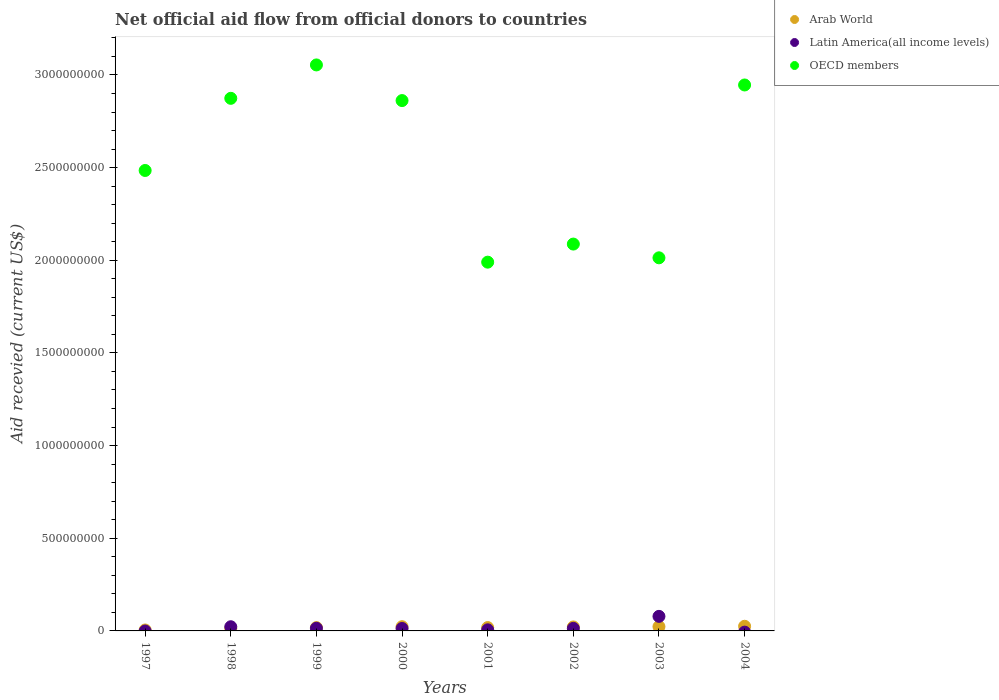How many different coloured dotlines are there?
Make the answer very short. 3. Is the number of dotlines equal to the number of legend labels?
Ensure brevity in your answer.  No. What is the total aid received in OECD members in 2000?
Ensure brevity in your answer.  2.86e+09. Across all years, what is the maximum total aid received in Arab World?
Ensure brevity in your answer.  2.51e+07. In which year was the total aid received in Arab World maximum?
Your answer should be compact. 2004. What is the total total aid received in Latin America(all income levels) in the graph?
Make the answer very short. 1.48e+08. What is the difference between the total aid received in OECD members in 2001 and that in 2003?
Give a very brief answer. -2.34e+07. What is the difference between the total aid received in OECD members in 1998 and the total aid received in Latin America(all income levels) in 1999?
Ensure brevity in your answer.  2.86e+09. What is the average total aid received in Latin America(all income levels) per year?
Offer a very short reply. 1.85e+07. In the year 2003, what is the difference between the total aid received in Arab World and total aid received in Latin America(all income levels)?
Ensure brevity in your answer.  -5.53e+07. In how many years, is the total aid received in OECD members greater than 1100000000 US$?
Ensure brevity in your answer.  8. What is the ratio of the total aid received in OECD members in 1998 to that in 2004?
Make the answer very short. 0.98. Is the total aid received in OECD members in 2000 less than that in 2004?
Provide a succinct answer. Yes. What is the difference between the highest and the second highest total aid received in Arab World?
Give a very brief answer. 1.86e+06. What is the difference between the highest and the lowest total aid received in OECD members?
Ensure brevity in your answer.  1.06e+09. Is the sum of the total aid received in OECD members in 2000 and 2002 greater than the maximum total aid received in Latin America(all income levels) across all years?
Provide a succinct answer. Yes. How many years are there in the graph?
Provide a short and direct response. 8. Does the graph contain grids?
Ensure brevity in your answer.  No. How many legend labels are there?
Provide a succinct answer. 3. What is the title of the graph?
Make the answer very short. Net official aid flow from official donors to countries. What is the label or title of the Y-axis?
Provide a short and direct response. Aid recevied (current US$). What is the Aid recevied (current US$) in Arab World in 1997?
Keep it short and to the point. 5.08e+06. What is the Aid recevied (current US$) in OECD members in 1997?
Provide a succinct answer. 2.48e+09. What is the Aid recevied (current US$) in Arab World in 1998?
Your answer should be compact. 1.31e+07. What is the Aid recevied (current US$) in Latin America(all income levels) in 1998?
Provide a short and direct response. 2.25e+07. What is the Aid recevied (current US$) of OECD members in 1998?
Offer a terse response. 2.87e+09. What is the Aid recevied (current US$) in Arab World in 1999?
Make the answer very short. 1.80e+07. What is the Aid recevied (current US$) of Latin America(all income levels) in 1999?
Ensure brevity in your answer.  1.43e+07. What is the Aid recevied (current US$) of OECD members in 1999?
Provide a short and direct response. 3.05e+09. What is the Aid recevied (current US$) of Arab World in 2000?
Provide a short and direct response. 2.28e+07. What is the Aid recevied (current US$) in Latin America(all income levels) in 2000?
Ensure brevity in your answer.  1.31e+07. What is the Aid recevied (current US$) of OECD members in 2000?
Your answer should be very brief. 2.86e+09. What is the Aid recevied (current US$) of Arab World in 2001?
Offer a terse response. 1.81e+07. What is the Aid recevied (current US$) of Latin America(all income levels) in 2001?
Your answer should be very brief. 5.97e+06. What is the Aid recevied (current US$) in OECD members in 2001?
Keep it short and to the point. 1.99e+09. What is the Aid recevied (current US$) of Arab World in 2002?
Your answer should be very brief. 2.14e+07. What is the Aid recevied (current US$) of Latin America(all income levels) in 2002?
Your answer should be compact. 1.37e+07. What is the Aid recevied (current US$) of OECD members in 2002?
Provide a succinct answer. 2.09e+09. What is the Aid recevied (current US$) of Arab World in 2003?
Make the answer very short. 2.32e+07. What is the Aid recevied (current US$) in Latin America(all income levels) in 2003?
Your response must be concise. 7.86e+07. What is the Aid recevied (current US$) in OECD members in 2003?
Your answer should be very brief. 2.01e+09. What is the Aid recevied (current US$) in Arab World in 2004?
Offer a terse response. 2.51e+07. What is the Aid recevied (current US$) in OECD members in 2004?
Your answer should be compact. 2.95e+09. Across all years, what is the maximum Aid recevied (current US$) of Arab World?
Ensure brevity in your answer.  2.51e+07. Across all years, what is the maximum Aid recevied (current US$) in Latin America(all income levels)?
Your response must be concise. 7.86e+07. Across all years, what is the maximum Aid recevied (current US$) of OECD members?
Make the answer very short. 3.05e+09. Across all years, what is the minimum Aid recevied (current US$) of Arab World?
Keep it short and to the point. 5.08e+06. Across all years, what is the minimum Aid recevied (current US$) in Latin America(all income levels)?
Offer a terse response. 0. Across all years, what is the minimum Aid recevied (current US$) in OECD members?
Your answer should be very brief. 1.99e+09. What is the total Aid recevied (current US$) of Arab World in the graph?
Keep it short and to the point. 1.47e+08. What is the total Aid recevied (current US$) in Latin America(all income levels) in the graph?
Your response must be concise. 1.48e+08. What is the total Aid recevied (current US$) in OECD members in the graph?
Give a very brief answer. 2.03e+1. What is the difference between the Aid recevied (current US$) of Arab World in 1997 and that in 1998?
Make the answer very short. -8.03e+06. What is the difference between the Aid recevied (current US$) of OECD members in 1997 and that in 1998?
Make the answer very short. -3.89e+08. What is the difference between the Aid recevied (current US$) in Arab World in 1997 and that in 1999?
Make the answer very short. -1.29e+07. What is the difference between the Aid recevied (current US$) in OECD members in 1997 and that in 1999?
Offer a terse response. -5.70e+08. What is the difference between the Aid recevied (current US$) of Arab World in 1997 and that in 2000?
Provide a short and direct response. -1.77e+07. What is the difference between the Aid recevied (current US$) of OECD members in 1997 and that in 2000?
Offer a very short reply. -3.77e+08. What is the difference between the Aid recevied (current US$) of Arab World in 1997 and that in 2001?
Provide a short and direct response. -1.30e+07. What is the difference between the Aid recevied (current US$) of OECD members in 1997 and that in 2001?
Make the answer very short. 4.95e+08. What is the difference between the Aid recevied (current US$) in Arab World in 1997 and that in 2002?
Provide a succinct answer. -1.64e+07. What is the difference between the Aid recevied (current US$) in OECD members in 1997 and that in 2002?
Give a very brief answer. 3.97e+08. What is the difference between the Aid recevied (current US$) of Arab World in 1997 and that in 2003?
Provide a short and direct response. -1.82e+07. What is the difference between the Aid recevied (current US$) in OECD members in 1997 and that in 2003?
Provide a succinct answer. 4.71e+08. What is the difference between the Aid recevied (current US$) of Arab World in 1997 and that in 2004?
Offer a terse response. -2.00e+07. What is the difference between the Aid recevied (current US$) of OECD members in 1997 and that in 2004?
Make the answer very short. -4.61e+08. What is the difference between the Aid recevied (current US$) of Arab World in 1998 and that in 1999?
Provide a short and direct response. -4.89e+06. What is the difference between the Aid recevied (current US$) in Latin America(all income levels) in 1998 and that in 1999?
Offer a terse response. 8.20e+06. What is the difference between the Aid recevied (current US$) of OECD members in 1998 and that in 1999?
Provide a succinct answer. -1.80e+08. What is the difference between the Aid recevied (current US$) of Arab World in 1998 and that in 2000?
Keep it short and to the point. -9.67e+06. What is the difference between the Aid recevied (current US$) in Latin America(all income levels) in 1998 and that in 2000?
Make the answer very short. 9.40e+06. What is the difference between the Aid recevied (current US$) of OECD members in 1998 and that in 2000?
Provide a short and direct response. 1.22e+07. What is the difference between the Aid recevied (current US$) of Arab World in 1998 and that in 2001?
Keep it short and to the point. -5.00e+06. What is the difference between the Aid recevied (current US$) in Latin America(all income levels) in 1998 and that in 2001?
Make the answer very short. 1.66e+07. What is the difference between the Aid recevied (current US$) of OECD members in 1998 and that in 2001?
Give a very brief answer. 8.84e+08. What is the difference between the Aid recevied (current US$) of Arab World in 1998 and that in 2002?
Give a very brief answer. -8.33e+06. What is the difference between the Aid recevied (current US$) of Latin America(all income levels) in 1998 and that in 2002?
Make the answer very short. 8.82e+06. What is the difference between the Aid recevied (current US$) in OECD members in 1998 and that in 2002?
Your response must be concise. 7.86e+08. What is the difference between the Aid recevied (current US$) of Arab World in 1998 and that in 2003?
Offer a very short reply. -1.01e+07. What is the difference between the Aid recevied (current US$) in Latin America(all income levels) in 1998 and that in 2003?
Your response must be concise. -5.60e+07. What is the difference between the Aid recevied (current US$) of OECD members in 1998 and that in 2003?
Offer a very short reply. 8.61e+08. What is the difference between the Aid recevied (current US$) of Arab World in 1998 and that in 2004?
Your answer should be very brief. -1.20e+07. What is the difference between the Aid recevied (current US$) of OECD members in 1998 and that in 2004?
Ensure brevity in your answer.  -7.20e+07. What is the difference between the Aid recevied (current US$) of Arab World in 1999 and that in 2000?
Your answer should be compact. -4.78e+06. What is the difference between the Aid recevied (current US$) of Latin America(all income levels) in 1999 and that in 2000?
Give a very brief answer. 1.20e+06. What is the difference between the Aid recevied (current US$) in OECD members in 1999 and that in 2000?
Offer a very short reply. 1.92e+08. What is the difference between the Aid recevied (current US$) of Latin America(all income levels) in 1999 and that in 2001?
Your response must be concise. 8.36e+06. What is the difference between the Aid recevied (current US$) in OECD members in 1999 and that in 2001?
Offer a terse response. 1.06e+09. What is the difference between the Aid recevied (current US$) in Arab World in 1999 and that in 2002?
Your answer should be very brief. -3.44e+06. What is the difference between the Aid recevied (current US$) of Latin America(all income levels) in 1999 and that in 2002?
Ensure brevity in your answer.  6.20e+05. What is the difference between the Aid recevied (current US$) of OECD members in 1999 and that in 2002?
Your answer should be very brief. 9.67e+08. What is the difference between the Aid recevied (current US$) of Arab World in 1999 and that in 2003?
Provide a succinct answer. -5.25e+06. What is the difference between the Aid recevied (current US$) in Latin America(all income levels) in 1999 and that in 2003?
Keep it short and to the point. -6.42e+07. What is the difference between the Aid recevied (current US$) of OECD members in 1999 and that in 2003?
Ensure brevity in your answer.  1.04e+09. What is the difference between the Aid recevied (current US$) of Arab World in 1999 and that in 2004?
Provide a short and direct response. -7.11e+06. What is the difference between the Aid recevied (current US$) in OECD members in 1999 and that in 2004?
Provide a succinct answer. 1.08e+08. What is the difference between the Aid recevied (current US$) of Arab World in 2000 and that in 2001?
Give a very brief answer. 4.67e+06. What is the difference between the Aid recevied (current US$) of Latin America(all income levels) in 2000 and that in 2001?
Provide a succinct answer. 7.16e+06. What is the difference between the Aid recevied (current US$) in OECD members in 2000 and that in 2001?
Ensure brevity in your answer.  8.72e+08. What is the difference between the Aid recevied (current US$) of Arab World in 2000 and that in 2002?
Your answer should be very brief. 1.34e+06. What is the difference between the Aid recevied (current US$) of Latin America(all income levels) in 2000 and that in 2002?
Give a very brief answer. -5.80e+05. What is the difference between the Aid recevied (current US$) in OECD members in 2000 and that in 2002?
Make the answer very short. 7.74e+08. What is the difference between the Aid recevied (current US$) in Arab World in 2000 and that in 2003?
Offer a very short reply. -4.70e+05. What is the difference between the Aid recevied (current US$) of Latin America(all income levels) in 2000 and that in 2003?
Your answer should be very brief. -6.54e+07. What is the difference between the Aid recevied (current US$) of OECD members in 2000 and that in 2003?
Provide a short and direct response. 8.48e+08. What is the difference between the Aid recevied (current US$) in Arab World in 2000 and that in 2004?
Provide a short and direct response. -2.33e+06. What is the difference between the Aid recevied (current US$) in OECD members in 2000 and that in 2004?
Make the answer very short. -8.42e+07. What is the difference between the Aid recevied (current US$) of Arab World in 2001 and that in 2002?
Offer a terse response. -3.33e+06. What is the difference between the Aid recevied (current US$) of Latin America(all income levels) in 2001 and that in 2002?
Provide a short and direct response. -7.74e+06. What is the difference between the Aid recevied (current US$) in OECD members in 2001 and that in 2002?
Make the answer very short. -9.76e+07. What is the difference between the Aid recevied (current US$) of Arab World in 2001 and that in 2003?
Keep it short and to the point. -5.14e+06. What is the difference between the Aid recevied (current US$) of Latin America(all income levels) in 2001 and that in 2003?
Give a very brief answer. -7.26e+07. What is the difference between the Aid recevied (current US$) of OECD members in 2001 and that in 2003?
Your answer should be compact. -2.34e+07. What is the difference between the Aid recevied (current US$) in Arab World in 2001 and that in 2004?
Offer a terse response. -7.00e+06. What is the difference between the Aid recevied (current US$) of OECD members in 2001 and that in 2004?
Provide a succinct answer. -9.56e+08. What is the difference between the Aid recevied (current US$) of Arab World in 2002 and that in 2003?
Offer a terse response. -1.81e+06. What is the difference between the Aid recevied (current US$) of Latin America(all income levels) in 2002 and that in 2003?
Your answer should be compact. -6.49e+07. What is the difference between the Aid recevied (current US$) in OECD members in 2002 and that in 2003?
Offer a very short reply. 7.41e+07. What is the difference between the Aid recevied (current US$) of Arab World in 2002 and that in 2004?
Provide a short and direct response. -3.67e+06. What is the difference between the Aid recevied (current US$) of OECD members in 2002 and that in 2004?
Your answer should be compact. -8.58e+08. What is the difference between the Aid recevied (current US$) of Arab World in 2003 and that in 2004?
Offer a very short reply. -1.86e+06. What is the difference between the Aid recevied (current US$) of OECD members in 2003 and that in 2004?
Offer a very short reply. -9.33e+08. What is the difference between the Aid recevied (current US$) of Arab World in 1997 and the Aid recevied (current US$) of Latin America(all income levels) in 1998?
Ensure brevity in your answer.  -1.74e+07. What is the difference between the Aid recevied (current US$) in Arab World in 1997 and the Aid recevied (current US$) in OECD members in 1998?
Your response must be concise. -2.87e+09. What is the difference between the Aid recevied (current US$) in Arab World in 1997 and the Aid recevied (current US$) in Latin America(all income levels) in 1999?
Offer a very short reply. -9.25e+06. What is the difference between the Aid recevied (current US$) of Arab World in 1997 and the Aid recevied (current US$) of OECD members in 1999?
Ensure brevity in your answer.  -3.05e+09. What is the difference between the Aid recevied (current US$) of Arab World in 1997 and the Aid recevied (current US$) of Latin America(all income levels) in 2000?
Ensure brevity in your answer.  -8.05e+06. What is the difference between the Aid recevied (current US$) in Arab World in 1997 and the Aid recevied (current US$) in OECD members in 2000?
Provide a short and direct response. -2.86e+09. What is the difference between the Aid recevied (current US$) of Arab World in 1997 and the Aid recevied (current US$) of Latin America(all income levels) in 2001?
Give a very brief answer. -8.90e+05. What is the difference between the Aid recevied (current US$) in Arab World in 1997 and the Aid recevied (current US$) in OECD members in 2001?
Make the answer very short. -1.98e+09. What is the difference between the Aid recevied (current US$) of Arab World in 1997 and the Aid recevied (current US$) of Latin America(all income levels) in 2002?
Ensure brevity in your answer.  -8.63e+06. What is the difference between the Aid recevied (current US$) in Arab World in 1997 and the Aid recevied (current US$) in OECD members in 2002?
Make the answer very short. -2.08e+09. What is the difference between the Aid recevied (current US$) of Arab World in 1997 and the Aid recevied (current US$) of Latin America(all income levels) in 2003?
Provide a short and direct response. -7.35e+07. What is the difference between the Aid recevied (current US$) in Arab World in 1997 and the Aid recevied (current US$) in OECD members in 2003?
Your answer should be compact. -2.01e+09. What is the difference between the Aid recevied (current US$) of Arab World in 1997 and the Aid recevied (current US$) of OECD members in 2004?
Ensure brevity in your answer.  -2.94e+09. What is the difference between the Aid recevied (current US$) of Arab World in 1998 and the Aid recevied (current US$) of Latin America(all income levels) in 1999?
Keep it short and to the point. -1.22e+06. What is the difference between the Aid recevied (current US$) of Arab World in 1998 and the Aid recevied (current US$) of OECD members in 1999?
Offer a very short reply. -3.04e+09. What is the difference between the Aid recevied (current US$) of Latin America(all income levels) in 1998 and the Aid recevied (current US$) of OECD members in 1999?
Provide a succinct answer. -3.03e+09. What is the difference between the Aid recevied (current US$) in Arab World in 1998 and the Aid recevied (current US$) in OECD members in 2000?
Offer a terse response. -2.85e+09. What is the difference between the Aid recevied (current US$) in Latin America(all income levels) in 1998 and the Aid recevied (current US$) in OECD members in 2000?
Provide a short and direct response. -2.84e+09. What is the difference between the Aid recevied (current US$) of Arab World in 1998 and the Aid recevied (current US$) of Latin America(all income levels) in 2001?
Offer a very short reply. 7.14e+06. What is the difference between the Aid recevied (current US$) of Arab World in 1998 and the Aid recevied (current US$) of OECD members in 2001?
Ensure brevity in your answer.  -1.98e+09. What is the difference between the Aid recevied (current US$) in Latin America(all income levels) in 1998 and the Aid recevied (current US$) in OECD members in 2001?
Your response must be concise. -1.97e+09. What is the difference between the Aid recevied (current US$) of Arab World in 1998 and the Aid recevied (current US$) of Latin America(all income levels) in 2002?
Keep it short and to the point. -6.00e+05. What is the difference between the Aid recevied (current US$) in Arab World in 1998 and the Aid recevied (current US$) in OECD members in 2002?
Your answer should be very brief. -2.07e+09. What is the difference between the Aid recevied (current US$) of Latin America(all income levels) in 1998 and the Aid recevied (current US$) of OECD members in 2002?
Make the answer very short. -2.06e+09. What is the difference between the Aid recevied (current US$) of Arab World in 1998 and the Aid recevied (current US$) of Latin America(all income levels) in 2003?
Make the answer very short. -6.55e+07. What is the difference between the Aid recevied (current US$) of Arab World in 1998 and the Aid recevied (current US$) of OECD members in 2003?
Provide a short and direct response. -2.00e+09. What is the difference between the Aid recevied (current US$) in Latin America(all income levels) in 1998 and the Aid recevied (current US$) in OECD members in 2003?
Offer a terse response. -1.99e+09. What is the difference between the Aid recevied (current US$) of Arab World in 1998 and the Aid recevied (current US$) of OECD members in 2004?
Your response must be concise. -2.93e+09. What is the difference between the Aid recevied (current US$) of Latin America(all income levels) in 1998 and the Aid recevied (current US$) of OECD members in 2004?
Make the answer very short. -2.92e+09. What is the difference between the Aid recevied (current US$) in Arab World in 1999 and the Aid recevied (current US$) in Latin America(all income levels) in 2000?
Provide a succinct answer. 4.87e+06. What is the difference between the Aid recevied (current US$) of Arab World in 1999 and the Aid recevied (current US$) of OECD members in 2000?
Offer a very short reply. -2.84e+09. What is the difference between the Aid recevied (current US$) of Latin America(all income levels) in 1999 and the Aid recevied (current US$) of OECD members in 2000?
Provide a succinct answer. -2.85e+09. What is the difference between the Aid recevied (current US$) of Arab World in 1999 and the Aid recevied (current US$) of Latin America(all income levels) in 2001?
Your answer should be very brief. 1.20e+07. What is the difference between the Aid recevied (current US$) of Arab World in 1999 and the Aid recevied (current US$) of OECD members in 2001?
Your answer should be very brief. -1.97e+09. What is the difference between the Aid recevied (current US$) in Latin America(all income levels) in 1999 and the Aid recevied (current US$) in OECD members in 2001?
Keep it short and to the point. -1.98e+09. What is the difference between the Aid recevied (current US$) in Arab World in 1999 and the Aid recevied (current US$) in Latin America(all income levels) in 2002?
Your answer should be compact. 4.29e+06. What is the difference between the Aid recevied (current US$) in Arab World in 1999 and the Aid recevied (current US$) in OECD members in 2002?
Your answer should be very brief. -2.07e+09. What is the difference between the Aid recevied (current US$) in Latin America(all income levels) in 1999 and the Aid recevied (current US$) in OECD members in 2002?
Provide a short and direct response. -2.07e+09. What is the difference between the Aid recevied (current US$) of Arab World in 1999 and the Aid recevied (current US$) of Latin America(all income levels) in 2003?
Your answer should be very brief. -6.06e+07. What is the difference between the Aid recevied (current US$) of Arab World in 1999 and the Aid recevied (current US$) of OECD members in 2003?
Provide a short and direct response. -2.00e+09. What is the difference between the Aid recevied (current US$) in Latin America(all income levels) in 1999 and the Aid recevied (current US$) in OECD members in 2003?
Keep it short and to the point. -2.00e+09. What is the difference between the Aid recevied (current US$) of Arab World in 1999 and the Aid recevied (current US$) of OECD members in 2004?
Ensure brevity in your answer.  -2.93e+09. What is the difference between the Aid recevied (current US$) of Latin America(all income levels) in 1999 and the Aid recevied (current US$) of OECD members in 2004?
Your response must be concise. -2.93e+09. What is the difference between the Aid recevied (current US$) in Arab World in 2000 and the Aid recevied (current US$) in Latin America(all income levels) in 2001?
Your response must be concise. 1.68e+07. What is the difference between the Aid recevied (current US$) in Arab World in 2000 and the Aid recevied (current US$) in OECD members in 2001?
Your answer should be very brief. -1.97e+09. What is the difference between the Aid recevied (current US$) of Latin America(all income levels) in 2000 and the Aid recevied (current US$) of OECD members in 2001?
Provide a short and direct response. -1.98e+09. What is the difference between the Aid recevied (current US$) of Arab World in 2000 and the Aid recevied (current US$) of Latin America(all income levels) in 2002?
Offer a terse response. 9.07e+06. What is the difference between the Aid recevied (current US$) of Arab World in 2000 and the Aid recevied (current US$) of OECD members in 2002?
Your answer should be very brief. -2.06e+09. What is the difference between the Aid recevied (current US$) in Latin America(all income levels) in 2000 and the Aid recevied (current US$) in OECD members in 2002?
Give a very brief answer. -2.07e+09. What is the difference between the Aid recevied (current US$) of Arab World in 2000 and the Aid recevied (current US$) of Latin America(all income levels) in 2003?
Your answer should be very brief. -5.58e+07. What is the difference between the Aid recevied (current US$) in Arab World in 2000 and the Aid recevied (current US$) in OECD members in 2003?
Offer a very short reply. -1.99e+09. What is the difference between the Aid recevied (current US$) in Latin America(all income levels) in 2000 and the Aid recevied (current US$) in OECD members in 2003?
Provide a short and direct response. -2.00e+09. What is the difference between the Aid recevied (current US$) in Arab World in 2000 and the Aid recevied (current US$) in OECD members in 2004?
Offer a terse response. -2.92e+09. What is the difference between the Aid recevied (current US$) in Latin America(all income levels) in 2000 and the Aid recevied (current US$) in OECD members in 2004?
Your answer should be compact. -2.93e+09. What is the difference between the Aid recevied (current US$) in Arab World in 2001 and the Aid recevied (current US$) in Latin America(all income levels) in 2002?
Offer a very short reply. 4.40e+06. What is the difference between the Aid recevied (current US$) of Arab World in 2001 and the Aid recevied (current US$) of OECD members in 2002?
Provide a succinct answer. -2.07e+09. What is the difference between the Aid recevied (current US$) of Latin America(all income levels) in 2001 and the Aid recevied (current US$) of OECD members in 2002?
Your answer should be compact. -2.08e+09. What is the difference between the Aid recevied (current US$) of Arab World in 2001 and the Aid recevied (current US$) of Latin America(all income levels) in 2003?
Your answer should be very brief. -6.05e+07. What is the difference between the Aid recevied (current US$) in Arab World in 2001 and the Aid recevied (current US$) in OECD members in 2003?
Offer a very short reply. -2.00e+09. What is the difference between the Aid recevied (current US$) of Latin America(all income levels) in 2001 and the Aid recevied (current US$) of OECD members in 2003?
Keep it short and to the point. -2.01e+09. What is the difference between the Aid recevied (current US$) of Arab World in 2001 and the Aid recevied (current US$) of OECD members in 2004?
Offer a very short reply. -2.93e+09. What is the difference between the Aid recevied (current US$) of Latin America(all income levels) in 2001 and the Aid recevied (current US$) of OECD members in 2004?
Make the answer very short. -2.94e+09. What is the difference between the Aid recevied (current US$) of Arab World in 2002 and the Aid recevied (current US$) of Latin America(all income levels) in 2003?
Make the answer very short. -5.71e+07. What is the difference between the Aid recevied (current US$) of Arab World in 2002 and the Aid recevied (current US$) of OECD members in 2003?
Your answer should be very brief. -1.99e+09. What is the difference between the Aid recevied (current US$) of Latin America(all income levels) in 2002 and the Aid recevied (current US$) of OECD members in 2003?
Your answer should be compact. -2.00e+09. What is the difference between the Aid recevied (current US$) in Arab World in 2002 and the Aid recevied (current US$) in OECD members in 2004?
Offer a terse response. -2.92e+09. What is the difference between the Aid recevied (current US$) in Latin America(all income levels) in 2002 and the Aid recevied (current US$) in OECD members in 2004?
Your response must be concise. -2.93e+09. What is the difference between the Aid recevied (current US$) of Arab World in 2003 and the Aid recevied (current US$) of OECD members in 2004?
Your response must be concise. -2.92e+09. What is the difference between the Aid recevied (current US$) of Latin America(all income levels) in 2003 and the Aid recevied (current US$) of OECD members in 2004?
Your answer should be compact. -2.87e+09. What is the average Aid recevied (current US$) of Arab World per year?
Offer a very short reply. 1.84e+07. What is the average Aid recevied (current US$) in Latin America(all income levels) per year?
Give a very brief answer. 1.85e+07. What is the average Aid recevied (current US$) in OECD members per year?
Make the answer very short. 2.54e+09. In the year 1997, what is the difference between the Aid recevied (current US$) in Arab World and Aid recevied (current US$) in OECD members?
Your answer should be very brief. -2.48e+09. In the year 1998, what is the difference between the Aid recevied (current US$) of Arab World and Aid recevied (current US$) of Latin America(all income levels)?
Your answer should be very brief. -9.42e+06. In the year 1998, what is the difference between the Aid recevied (current US$) of Arab World and Aid recevied (current US$) of OECD members?
Your response must be concise. -2.86e+09. In the year 1998, what is the difference between the Aid recevied (current US$) in Latin America(all income levels) and Aid recevied (current US$) in OECD members?
Your answer should be very brief. -2.85e+09. In the year 1999, what is the difference between the Aid recevied (current US$) of Arab World and Aid recevied (current US$) of Latin America(all income levels)?
Give a very brief answer. 3.67e+06. In the year 1999, what is the difference between the Aid recevied (current US$) in Arab World and Aid recevied (current US$) in OECD members?
Ensure brevity in your answer.  -3.04e+09. In the year 1999, what is the difference between the Aid recevied (current US$) in Latin America(all income levels) and Aid recevied (current US$) in OECD members?
Give a very brief answer. -3.04e+09. In the year 2000, what is the difference between the Aid recevied (current US$) of Arab World and Aid recevied (current US$) of Latin America(all income levels)?
Offer a terse response. 9.65e+06. In the year 2000, what is the difference between the Aid recevied (current US$) in Arab World and Aid recevied (current US$) in OECD members?
Your answer should be very brief. -2.84e+09. In the year 2000, what is the difference between the Aid recevied (current US$) in Latin America(all income levels) and Aid recevied (current US$) in OECD members?
Your answer should be compact. -2.85e+09. In the year 2001, what is the difference between the Aid recevied (current US$) of Arab World and Aid recevied (current US$) of Latin America(all income levels)?
Ensure brevity in your answer.  1.21e+07. In the year 2001, what is the difference between the Aid recevied (current US$) in Arab World and Aid recevied (current US$) in OECD members?
Keep it short and to the point. -1.97e+09. In the year 2001, what is the difference between the Aid recevied (current US$) of Latin America(all income levels) and Aid recevied (current US$) of OECD members?
Ensure brevity in your answer.  -1.98e+09. In the year 2002, what is the difference between the Aid recevied (current US$) of Arab World and Aid recevied (current US$) of Latin America(all income levels)?
Your response must be concise. 7.73e+06. In the year 2002, what is the difference between the Aid recevied (current US$) in Arab World and Aid recevied (current US$) in OECD members?
Ensure brevity in your answer.  -2.07e+09. In the year 2002, what is the difference between the Aid recevied (current US$) in Latin America(all income levels) and Aid recevied (current US$) in OECD members?
Your answer should be compact. -2.07e+09. In the year 2003, what is the difference between the Aid recevied (current US$) in Arab World and Aid recevied (current US$) in Latin America(all income levels)?
Offer a very short reply. -5.53e+07. In the year 2003, what is the difference between the Aid recevied (current US$) in Arab World and Aid recevied (current US$) in OECD members?
Offer a very short reply. -1.99e+09. In the year 2003, what is the difference between the Aid recevied (current US$) in Latin America(all income levels) and Aid recevied (current US$) in OECD members?
Make the answer very short. -1.93e+09. In the year 2004, what is the difference between the Aid recevied (current US$) of Arab World and Aid recevied (current US$) of OECD members?
Provide a succinct answer. -2.92e+09. What is the ratio of the Aid recevied (current US$) of Arab World in 1997 to that in 1998?
Offer a terse response. 0.39. What is the ratio of the Aid recevied (current US$) of OECD members in 1997 to that in 1998?
Provide a succinct answer. 0.86. What is the ratio of the Aid recevied (current US$) of Arab World in 1997 to that in 1999?
Give a very brief answer. 0.28. What is the ratio of the Aid recevied (current US$) in OECD members in 1997 to that in 1999?
Ensure brevity in your answer.  0.81. What is the ratio of the Aid recevied (current US$) in Arab World in 1997 to that in 2000?
Offer a very short reply. 0.22. What is the ratio of the Aid recevied (current US$) of OECD members in 1997 to that in 2000?
Provide a succinct answer. 0.87. What is the ratio of the Aid recevied (current US$) in Arab World in 1997 to that in 2001?
Offer a terse response. 0.28. What is the ratio of the Aid recevied (current US$) of OECD members in 1997 to that in 2001?
Offer a very short reply. 1.25. What is the ratio of the Aid recevied (current US$) of Arab World in 1997 to that in 2002?
Ensure brevity in your answer.  0.24. What is the ratio of the Aid recevied (current US$) of OECD members in 1997 to that in 2002?
Your answer should be very brief. 1.19. What is the ratio of the Aid recevied (current US$) of Arab World in 1997 to that in 2003?
Ensure brevity in your answer.  0.22. What is the ratio of the Aid recevied (current US$) in OECD members in 1997 to that in 2003?
Your response must be concise. 1.23. What is the ratio of the Aid recevied (current US$) of Arab World in 1997 to that in 2004?
Provide a succinct answer. 0.2. What is the ratio of the Aid recevied (current US$) in OECD members in 1997 to that in 2004?
Keep it short and to the point. 0.84. What is the ratio of the Aid recevied (current US$) in Arab World in 1998 to that in 1999?
Provide a short and direct response. 0.73. What is the ratio of the Aid recevied (current US$) of Latin America(all income levels) in 1998 to that in 1999?
Provide a short and direct response. 1.57. What is the ratio of the Aid recevied (current US$) of OECD members in 1998 to that in 1999?
Keep it short and to the point. 0.94. What is the ratio of the Aid recevied (current US$) in Arab World in 1998 to that in 2000?
Keep it short and to the point. 0.58. What is the ratio of the Aid recevied (current US$) of Latin America(all income levels) in 1998 to that in 2000?
Offer a terse response. 1.72. What is the ratio of the Aid recevied (current US$) in OECD members in 1998 to that in 2000?
Provide a short and direct response. 1. What is the ratio of the Aid recevied (current US$) of Arab World in 1998 to that in 2001?
Provide a succinct answer. 0.72. What is the ratio of the Aid recevied (current US$) of Latin America(all income levels) in 1998 to that in 2001?
Keep it short and to the point. 3.77. What is the ratio of the Aid recevied (current US$) of OECD members in 1998 to that in 2001?
Offer a very short reply. 1.44. What is the ratio of the Aid recevied (current US$) of Arab World in 1998 to that in 2002?
Your answer should be compact. 0.61. What is the ratio of the Aid recevied (current US$) of Latin America(all income levels) in 1998 to that in 2002?
Offer a terse response. 1.64. What is the ratio of the Aid recevied (current US$) in OECD members in 1998 to that in 2002?
Offer a terse response. 1.38. What is the ratio of the Aid recevied (current US$) in Arab World in 1998 to that in 2003?
Ensure brevity in your answer.  0.56. What is the ratio of the Aid recevied (current US$) in Latin America(all income levels) in 1998 to that in 2003?
Provide a short and direct response. 0.29. What is the ratio of the Aid recevied (current US$) of OECD members in 1998 to that in 2003?
Your answer should be compact. 1.43. What is the ratio of the Aid recevied (current US$) in Arab World in 1998 to that in 2004?
Keep it short and to the point. 0.52. What is the ratio of the Aid recevied (current US$) in OECD members in 1998 to that in 2004?
Make the answer very short. 0.98. What is the ratio of the Aid recevied (current US$) in Arab World in 1999 to that in 2000?
Your answer should be compact. 0.79. What is the ratio of the Aid recevied (current US$) in Latin America(all income levels) in 1999 to that in 2000?
Offer a very short reply. 1.09. What is the ratio of the Aid recevied (current US$) of OECD members in 1999 to that in 2000?
Ensure brevity in your answer.  1.07. What is the ratio of the Aid recevied (current US$) of Latin America(all income levels) in 1999 to that in 2001?
Your response must be concise. 2.4. What is the ratio of the Aid recevied (current US$) in OECD members in 1999 to that in 2001?
Make the answer very short. 1.53. What is the ratio of the Aid recevied (current US$) in Arab World in 1999 to that in 2002?
Ensure brevity in your answer.  0.84. What is the ratio of the Aid recevied (current US$) in Latin America(all income levels) in 1999 to that in 2002?
Your response must be concise. 1.05. What is the ratio of the Aid recevied (current US$) in OECD members in 1999 to that in 2002?
Offer a very short reply. 1.46. What is the ratio of the Aid recevied (current US$) of Arab World in 1999 to that in 2003?
Offer a very short reply. 0.77. What is the ratio of the Aid recevied (current US$) in Latin America(all income levels) in 1999 to that in 2003?
Offer a very short reply. 0.18. What is the ratio of the Aid recevied (current US$) in OECD members in 1999 to that in 2003?
Provide a short and direct response. 1.52. What is the ratio of the Aid recevied (current US$) of Arab World in 1999 to that in 2004?
Make the answer very short. 0.72. What is the ratio of the Aid recevied (current US$) of OECD members in 1999 to that in 2004?
Provide a succinct answer. 1.04. What is the ratio of the Aid recevied (current US$) in Arab World in 2000 to that in 2001?
Make the answer very short. 1.26. What is the ratio of the Aid recevied (current US$) in Latin America(all income levels) in 2000 to that in 2001?
Your answer should be very brief. 2.2. What is the ratio of the Aid recevied (current US$) of OECD members in 2000 to that in 2001?
Ensure brevity in your answer.  1.44. What is the ratio of the Aid recevied (current US$) in Arab World in 2000 to that in 2002?
Make the answer very short. 1.06. What is the ratio of the Aid recevied (current US$) in Latin America(all income levels) in 2000 to that in 2002?
Provide a succinct answer. 0.96. What is the ratio of the Aid recevied (current US$) in OECD members in 2000 to that in 2002?
Your answer should be very brief. 1.37. What is the ratio of the Aid recevied (current US$) of Arab World in 2000 to that in 2003?
Give a very brief answer. 0.98. What is the ratio of the Aid recevied (current US$) of Latin America(all income levels) in 2000 to that in 2003?
Your answer should be very brief. 0.17. What is the ratio of the Aid recevied (current US$) in OECD members in 2000 to that in 2003?
Provide a short and direct response. 1.42. What is the ratio of the Aid recevied (current US$) in Arab World in 2000 to that in 2004?
Provide a succinct answer. 0.91. What is the ratio of the Aid recevied (current US$) of OECD members in 2000 to that in 2004?
Provide a short and direct response. 0.97. What is the ratio of the Aid recevied (current US$) in Arab World in 2001 to that in 2002?
Provide a succinct answer. 0.84. What is the ratio of the Aid recevied (current US$) in Latin America(all income levels) in 2001 to that in 2002?
Make the answer very short. 0.44. What is the ratio of the Aid recevied (current US$) in OECD members in 2001 to that in 2002?
Offer a very short reply. 0.95. What is the ratio of the Aid recevied (current US$) of Arab World in 2001 to that in 2003?
Your answer should be very brief. 0.78. What is the ratio of the Aid recevied (current US$) in Latin America(all income levels) in 2001 to that in 2003?
Give a very brief answer. 0.08. What is the ratio of the Aid recevied (current US$) in OECD members in 2001 to that in 2003?
Your answer should be compact. 0.99. What is the ratio of the Aid recevied (current US$) in Arab World in 2001 to that in 2004?
Provide a short and direct response. 0.72. What is the ratio of the Aid recevied (current US$) in OECD members in 2001 to that in 2004?
Provide a short and direct response. 0.68. What is the ratio of the Aid recevied (current US$) of Arab World in 2002 to that in 2003?
Make the answer very short. 0.92. What is the ratio of the Aid recevied (current US$) in Latin America(all income levels) in 2002 to that in 2003?
Your answer should be very brief. 0.17. What is the ratio of the Aid recevied (current US$) of OECD members in 2002 to that in 2003?
Your answer should be compact. 1.04. What is the ratio of the Aid recevied (current US$) in Arab World in 2002 to that in 2004?
Make the answer very short. 0.85. What is the ratio of the Aid recevied (current US$) of OECD members in 2002 to that in 2004?
Provide a short and direct response. 0.71. What is the ratio of the Aid recevied (current US$) of Arab World in 2003 to that in 2004?
Offer a terse response. 0.93. What is the ratio of the Aid recevied (current US$) in OECD members in 2003 to that in 2004?
Offer a very short reply. 0.68. What is the difference between the highest and the second highest Aid recevied (current US$) in Arab World?
Provide a short and direct response. 1.86e+06. What is the difference between the highest and the second highest Aid recevied (current US$) in Latin America(all income levels)?
Make the answer very short. 5.60e+07. What is the difference between the highest and the second highest Aid recevied (current US$) of OECD members?
Your answer should be very brief. 1.08e+08. What is the difference between the highest and the lowest Aid recevied (current US$) of Arab World?
Make the answer very short. 2.00e+07. What is the difference between the highest and the lowest Aid recevied (current US$) of Latin America(all income levels)?
Your response must be concise. 7.86e+07. What is the difference between the highest and the lowest Aid recevied (current US$) in OECD members?
Offer a terse response. 1.06e+09. 